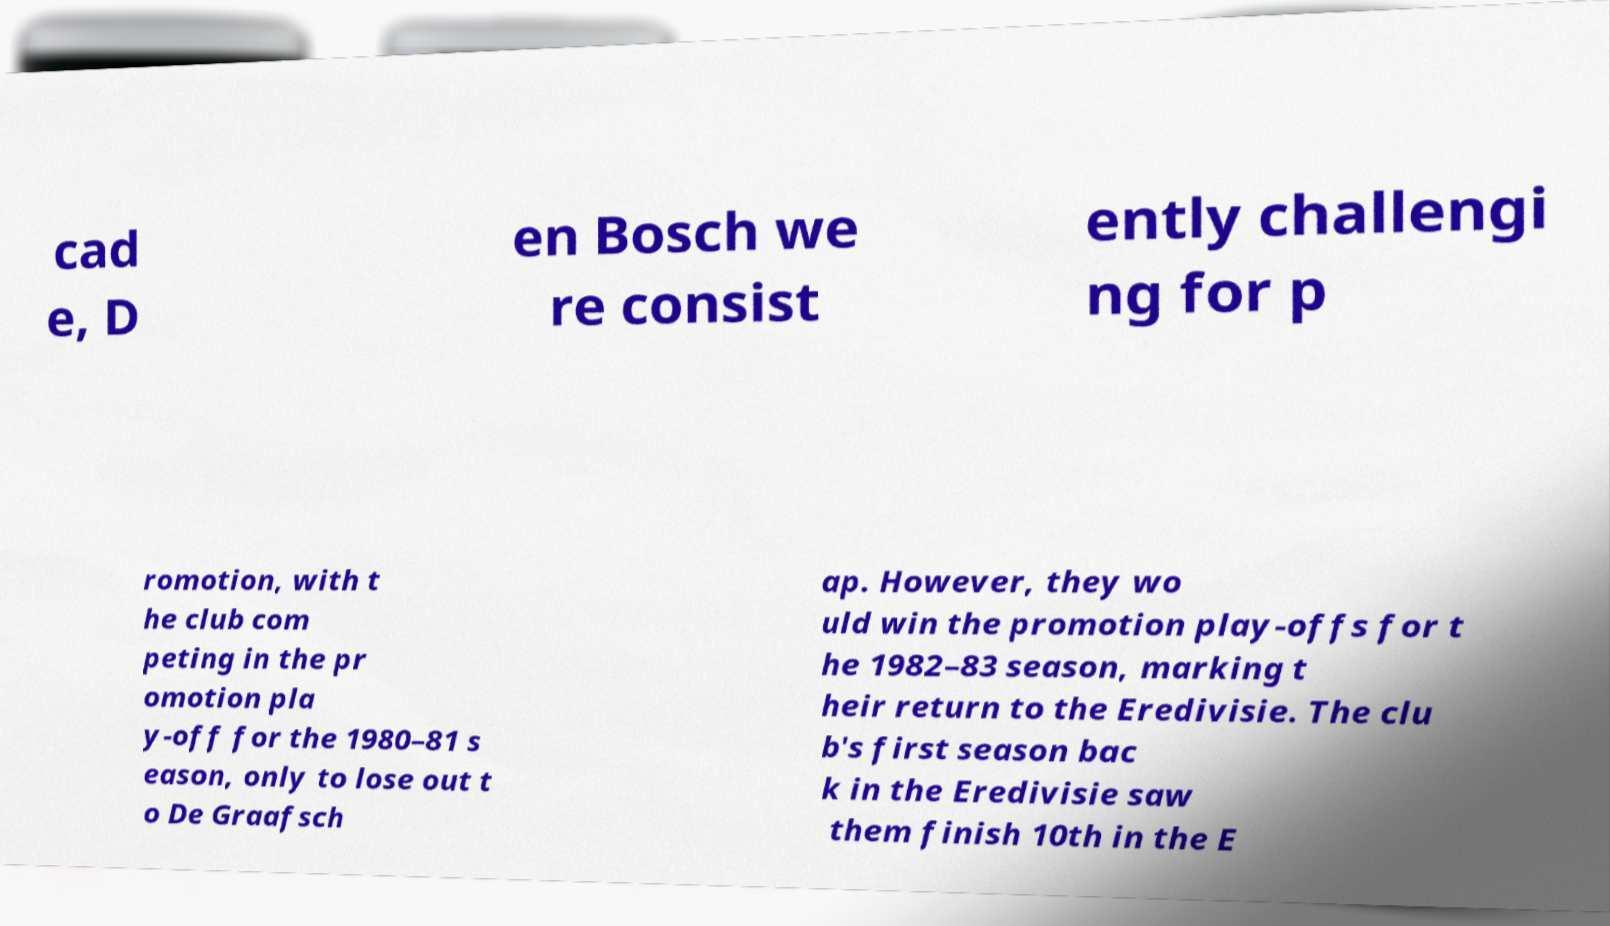There's text embedded in this image that I need extracted. Can you transcribe it verbatim? cad e, D en Bosch we re consist ently challengi ng for p romotion, with t he club com peting in the pr omotion pla y-off for the 1980–81 s eason, only to lose out t o De Graafsch ap. However, they wo uld win the promotion play-offs for t he 1982–83 season, marking t heir return to the Eredivisie. The clu b's first season bac k in the Eredivisie saw them finish 10th in the E 